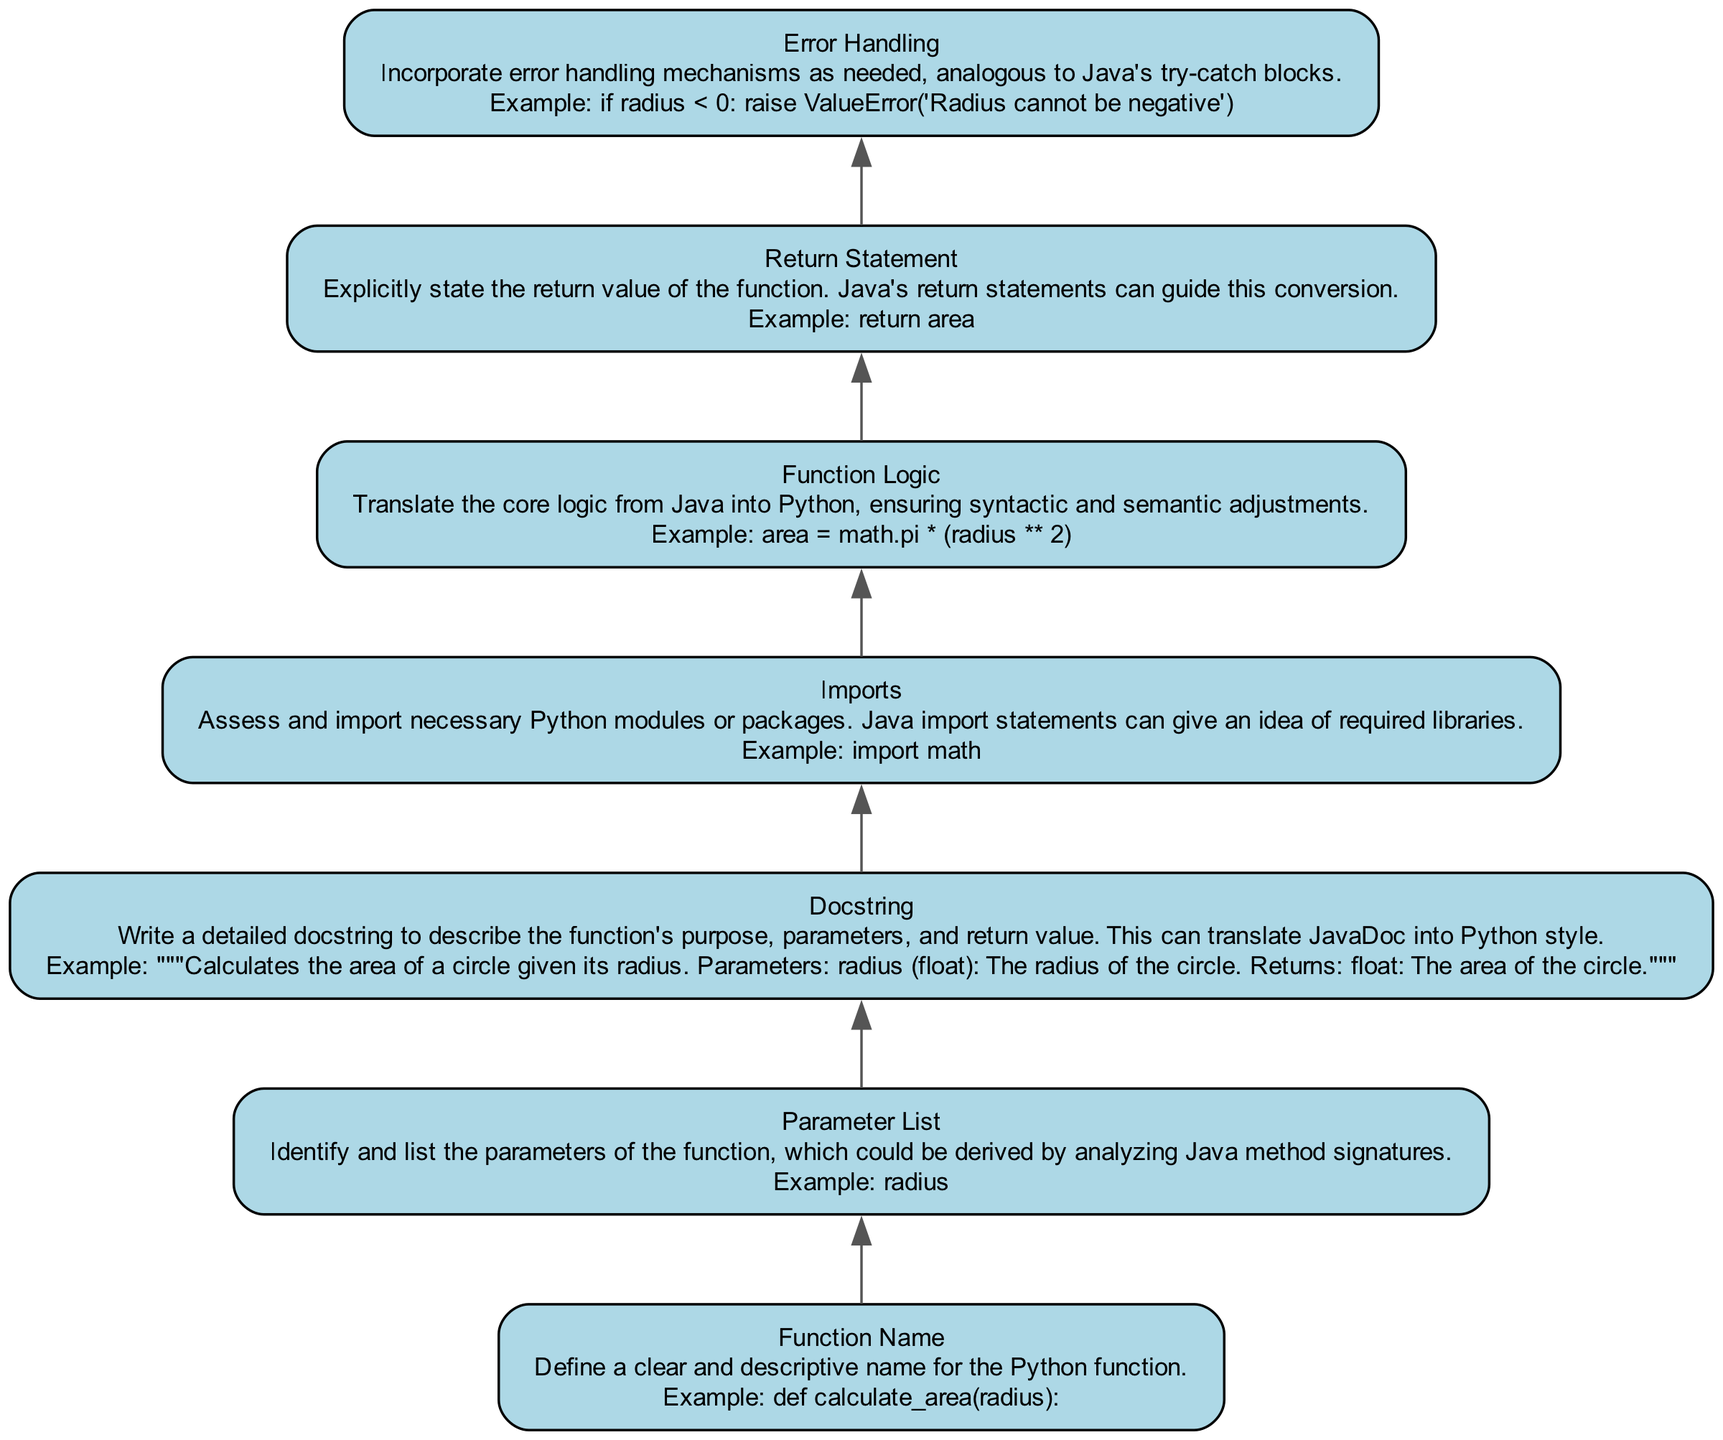What is the first step in converting a Java function to a Python function according to the diagram? The first step in the diagram is to define a clear and descriptive name for the Python function, which is represented by the node labeled "Function Name".
Answer: Define a clear and descriptive name What is the purpose of the docstring in the flowchart? The docstring serves to describe the function's purpose, parameters, and return value, translating JavaDoc into Python style, as mentioned in the "Docstring" node.
Answer: Describe function's purpose, parameters, and return value How many main steps are suggested in the conversion process? The diagram outlines seven main steps in the conversion process, each corresponding to a node in the flowchart.
Answer: Seven steps What is the example given for the function logic node? The example given for function logic is "area = math.pi * (radius ** 2)", illustrating the core calculation for the area.
Answer: area = math.pi * (radius ** 2) Which node addresses error handling in the conversion? The "Error Handling" node specifically addresses error handling in the conversion process, detailing the need for mechanisms analogous to Java's try-catch blocks.
Answer: Error Handling What can be deduced about the importance of imports in the function? The "Imports" node indicates that assessing and importing necessary Python modules is important, as Java import statements can hint at required libraries for functionality.
Answer: Assess and import necessary Python modules How does the return statement relate to the overall function according to the diagram? The "Return Statement" node emphasizes the necessity of explicitly stating the return value of the function, which is crucial for the function to output results, as guided by Java's return statements.
Answer: Explicitly state the return value 